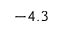<formula> <loc_0><loc_0><loc_500><loc_500>- 4 . 3</formula> 